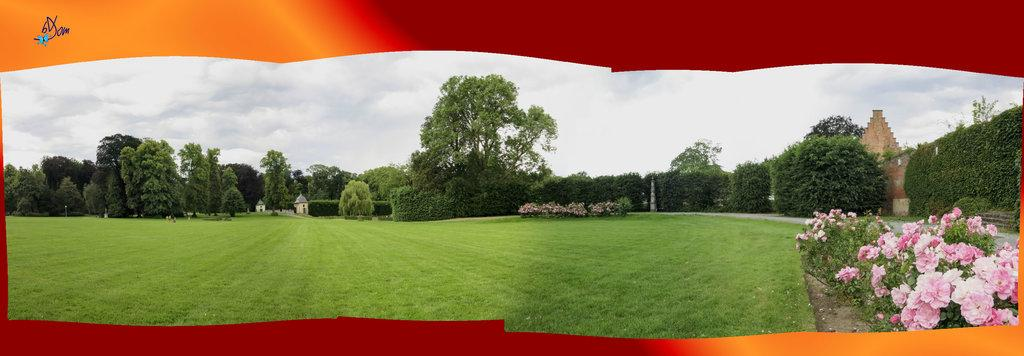What type of design is depicted in the image? The image appears to be a wallpaper. What colors are used for the border of the wallpaper? The wallpaper has a red and yellow color border. What is the main subject of the wallpaper? The main subject of the wallpaper is a garden. What type of vegetation is present in the garden? The garden is covered with grass and has flowers. What surrounds the garden in the wallpaper? The garden is surrounded by trees. Are there any structures within the garden? Yes, there are walls and poles in the garden. How is the sky depicted in the wallpaper? The sky is bright in the wallpaper. Can you see any fish swimming in the garden? There are no fish present in the garden depicted in the wallpaper. Who is leading the group of people walking through the garden? There are no people depicted in the garden; it only shows the garden, trees, and structures. 